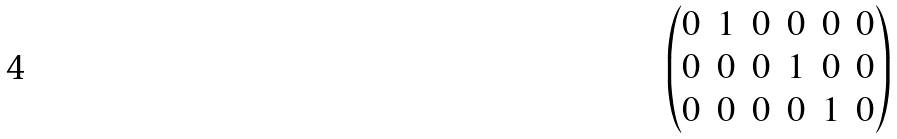Convert formula to latex. <formula><loc_0><loc_0><loc_500><loc_500>\begin{pmatrix} 0 & 1 & 0 & 0 & 0 & 0 \\ 0 & 0 & 0 & 1 & 0 & 0 \\ 0 & 0 & 0 & 0 & 1 & 0 \\ \end{pmatrix}</formula> 